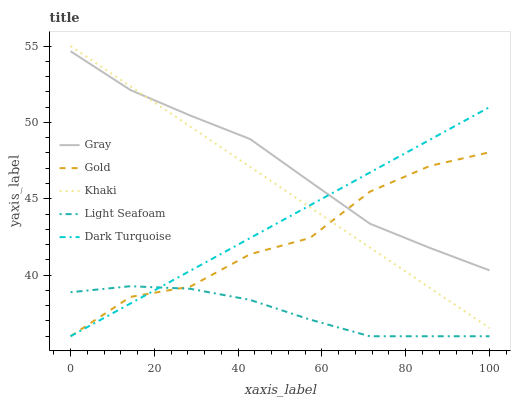Does Khaki have the minimum area under the curve?
Answer yes or no. No. Does Khaki have the maximum area under the curve?
Answer yes or no. No. Is Gray the smoothest?
Answer yes or no. No. Is Gray the roughest?
Answer yes or no. No. Does Khaki have the lowest value?
Answer yes or no. No. Does Gray have the highest value?
Answer yes or no. No. Is Light Seafoam less than Gray?
Answer yes or no. Yes. Is Khaki greater than Light Seafoam?
Answer yes or no. Yes. Does Light Seafoam intersect Gray?
Answer yes or no. No. 